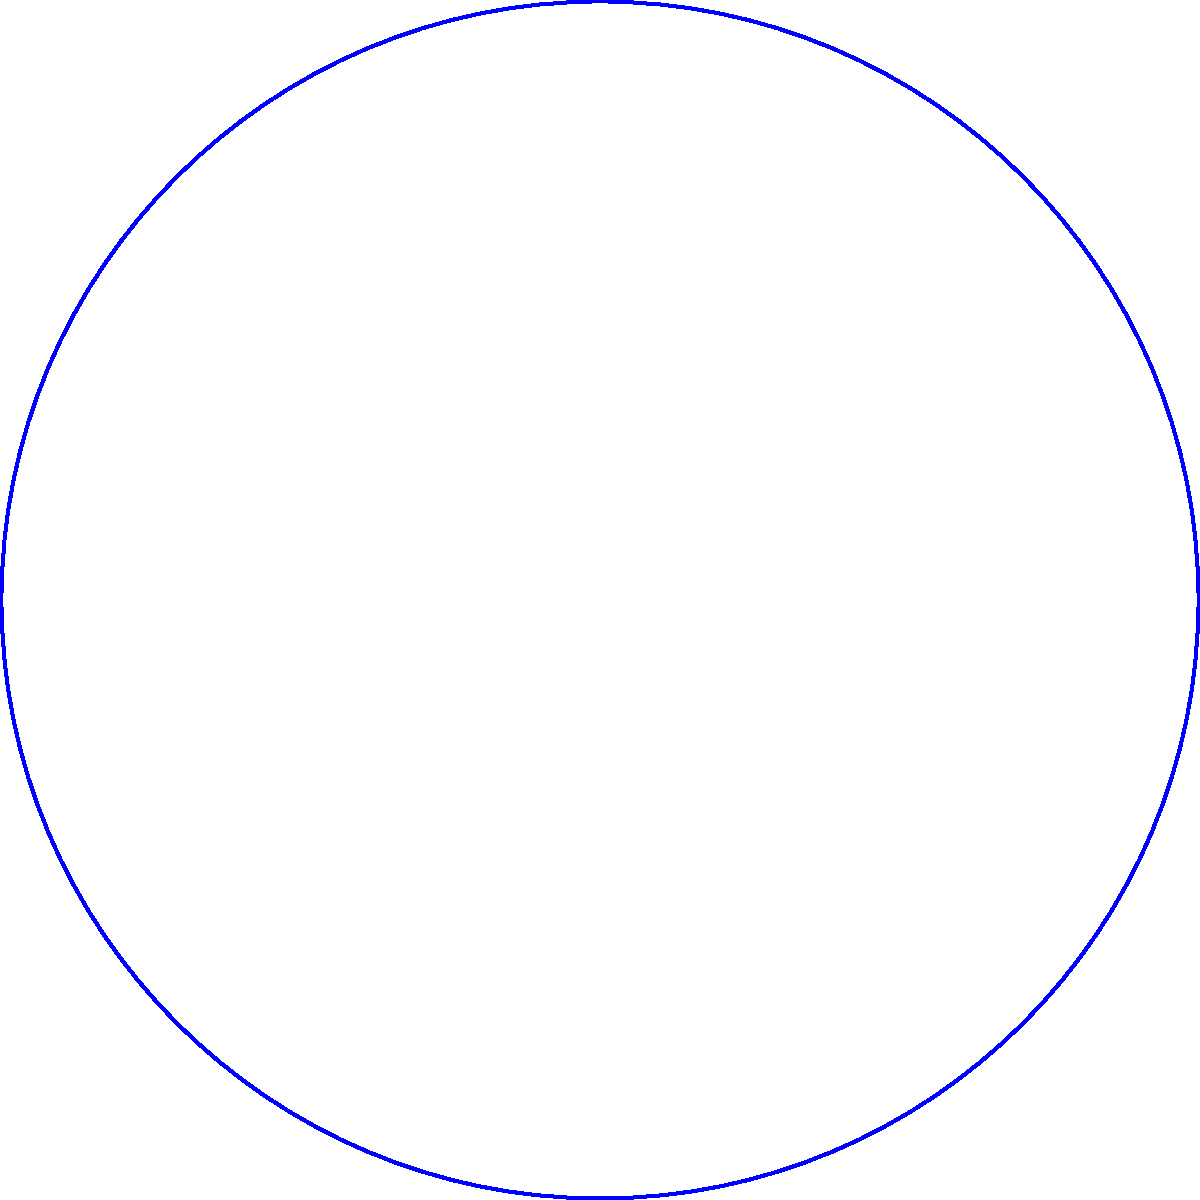As a cultural anthropologist studying diplomatic relations, you're analyzing the travel time between two diplomatic missions. The missions are located in cities A and B on Earth's surface, separated by a central angle of 60°. Given that the Earth's radius is approximately 6,371 km and a diplomat's flight travels at an average speed of 900 km/h along the great circle route, how long will the journey between the two missions take? To solve this problem, we'll use the concept of great circle distance and the given information:

1. Central angle between A and B: $\theta = 60° = \frac{\pi}{3}$ radians
2. Earth's radius: $R = 6,371$ km
3. Flight speed: $v = 900$ km/h

Step 1: Calculate the great circle distance (d) using the arc length formula:
$d = R \theta$
$d = 6,371 \times \frac{\pi}{3} \approx 6,671$ km

Step 2: Calculate the travel time (t) using the distance and speed:
$t = \frac{d}{v}$
$t = \frac{6,671}{900} \approx 7.41$ hours

Step 3: Convert the time to hours and minutes:
7.41 hours = 7 hours and 0.41 × 60 ≈ 25 minutes

Therefore, the journey between the two diplomatic missions will take approximately 7 hours and 25 minutes.
Answer: 7 hours and 25 minutes 